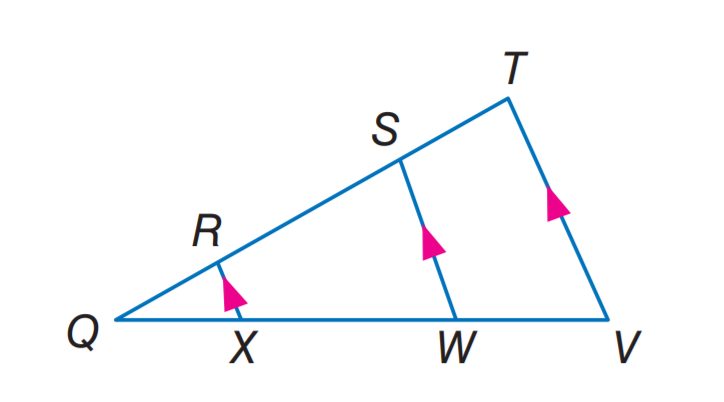Answer the mathemtical geometry problem and directly provide the correct option letter.
Question: If Q R = 2, X W = 12, Q W = 15, and S T = 5, find W V.
Choices: A: 5 B: 7.5 C: 8 D: 12 B 